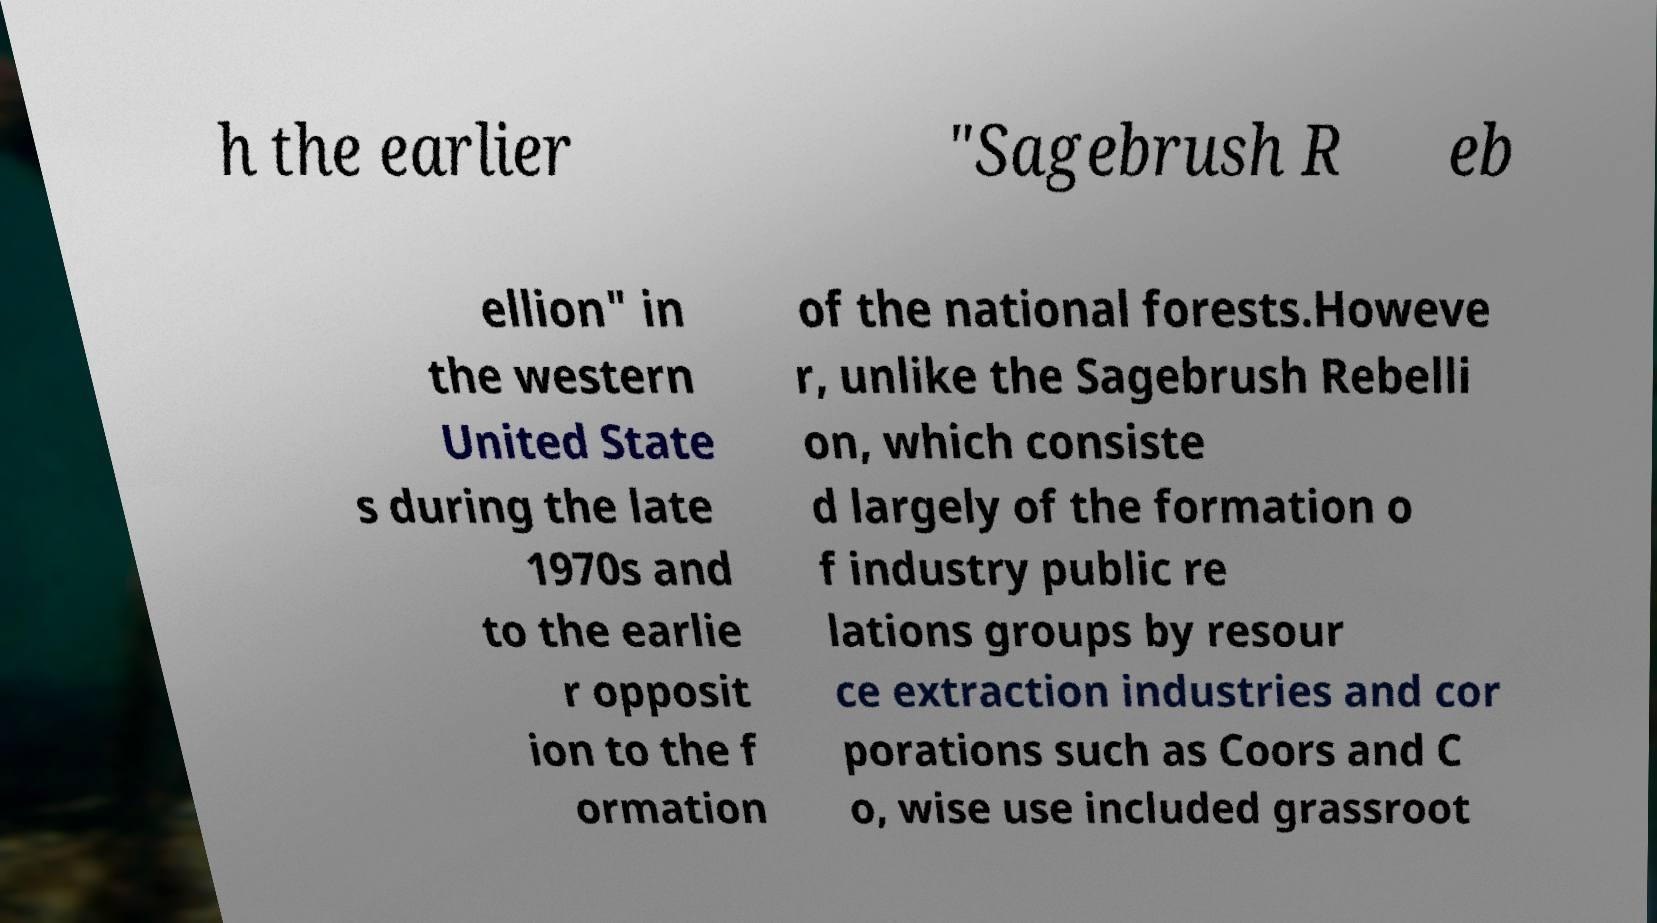I need the written content from this picture converted into text. Can you do that? h the earlier "Sagebrush R eb ellion" in the western United State s during the late 1970s and to the earlie r opposit ion to the f ormation of the national forests.Howeve r, unlike the Sagebrush Rebelli on, which consiste d largely of the formation o f industry public re lations groups by resour ce extraction industries and cor porations such as Coors and C o, wise use included grassroot 